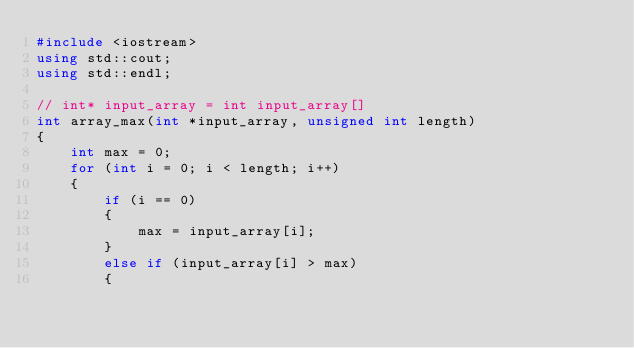Convert code to text. <code><loc_0><loc_0><loc_500><loc_500><_C++_>#include <iostream>
using std::cout;
using std::endl;

// int* input_array = int input_array[]
int array_max(int *input_array, unsigned int length)
{
    int max = 0;
    for (int i = 0; i < length; i++)
    {
        if (i == 0)
        {
            max = input_array[i];
        }
        else if (input_array[i] > max)
        {</code> 